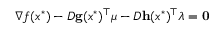Convert formula to latex. <formula><loc_0><loc_0><loc_500><loc_500>\nabla f ( x ^ { * } ) - D g ( x ^ { * } ) ^ { \top } { \mu } - D h ( x ^ { * } ) ^ { \top } { \lambda } = 0</formula> 